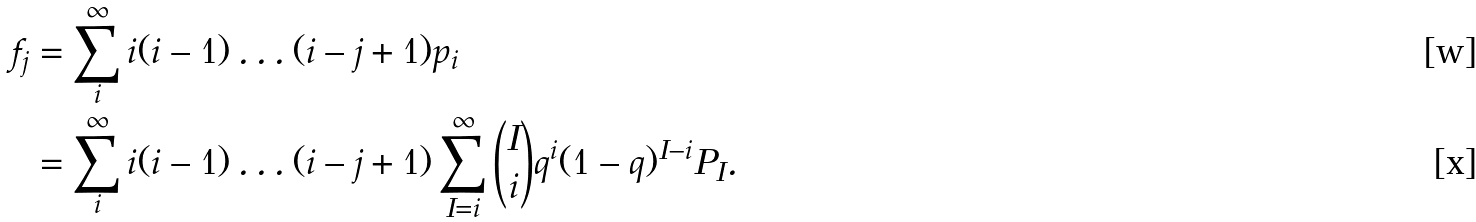Convert formula to latex. <formula><loc_0><loc_0><loc_500><loc_500>f _ { j } & = \sum _ { i } ^ { \infty } i ( i - 1 ) \dots ( i - j + 1 ) p _ { i } \\ & = \sum _ { i } ^ { \infty } i ( i - 1 ) \dots ( i - j + 1 ) \sum _ { I = i } ^ { \infty } \binom { I } { i } q ^ { i } ( 1 - q ) ^ { I - i } P _ { I } .</formula> 